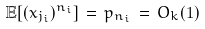<formula> <loc_0><loc_0><loc_500><loc_500>\mathbb { E } [ ( x _ { j _ { i } } ) ^ { n _ { i } } ] \, = \, p _ { n _ { i } } \, = \, O _ { k } ( 1 )</formula> 